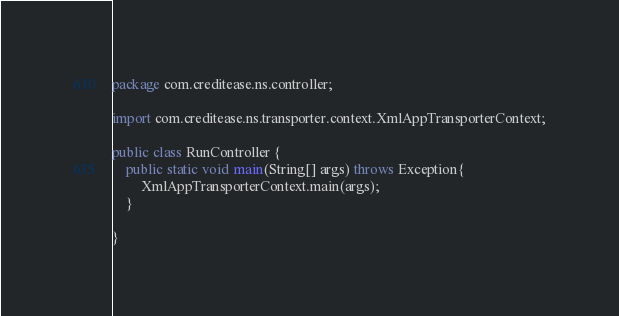<code> <loc_0><loc_0><loc_500><loc_500><_Java_>package com.creditease.ns.controller;

import com.creditease.ns.transporter.context.XmlAppTransporterContext;

public class RunController {
    public static void main(String[] args) throws Exception{
        XmlAppTransporterContext.main(args);
    }

}
</code> 